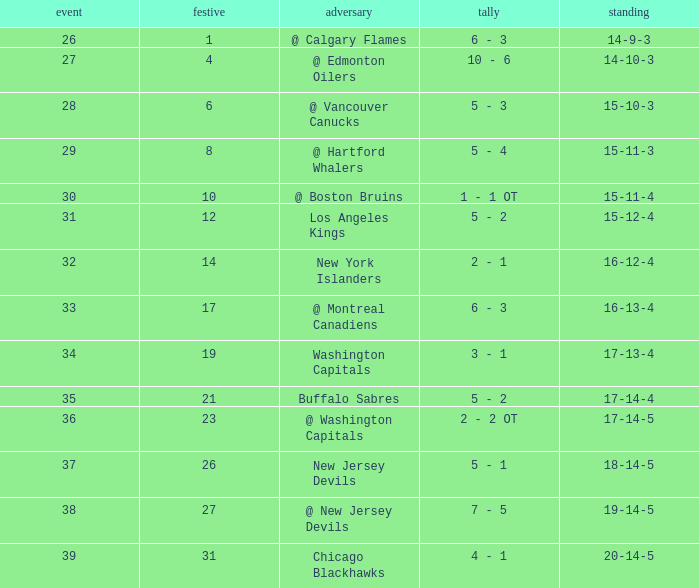Game smaller than 34, and a December smaller than 14, and a Score of 10 - 6 has what opponent? @ Edmonton Oilers. 